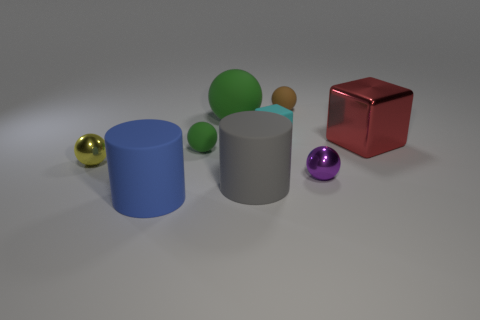Subtract 1 spheres. How many spheres are left? 4 Subtract all tiny yellow balls. How many balls are left? 4 Subtract all brown spheres. How many spheres are left? 4 Subtract all gray balls. Subtract all yellow cylinders. How many balls are left? 5 Add 1 small gray rubber cylinders. How many objects exist? 10 Subtract all spheres. How many objects are left? 4 Subtract 0 purple cylinders. How many objects are left? 9 Subtract all gray rubber things. Subtract all red metal blocks. How many objects are left? 7 Add 4 tiny green things. How many tiny green things are left? 5 Add 9 big blue metal blocks. How many big blue metal blocks exist? 9 